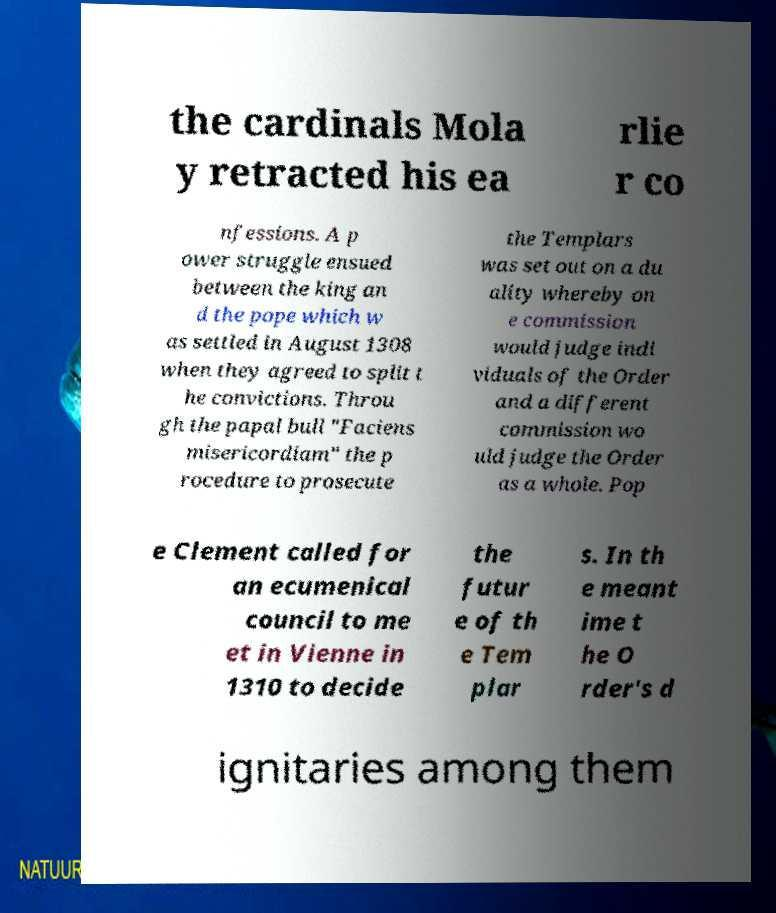Please identify and transcribe the text found in this image. the cardinals Mola y retracted his ea rlie r co nfessions. A p ower struggle ensued between the king an d the pope which w as settled in August 1308 when they agreed to split t he convictions. Throu gh the papal bull "Faciens misericordiam" the p rocedure to prosecute the Templars was set out on a du ality whereby on e commission would judge indi viduals of the Order and a different commission wo uld judge the Order as a whole. Pop e Clement called for an ecumenical council to me et in Vienne in 1310 to decide the futur e of th e Tem plar s. In th e meant ime t he O rder's d ignitaries among them 